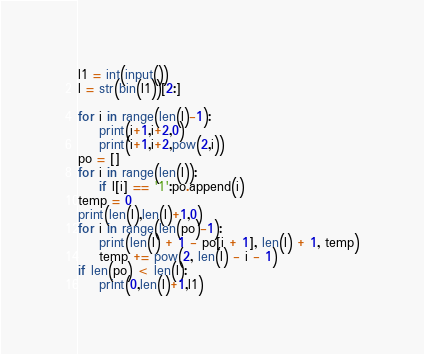Convert code to text. <code><loc_0><loc_0><loc_500><loc_500><_Python_>l1 = int(input())
l = str(bin(l1))[2:]

for i in range(len(l)-1):
    print(i+1,i+2,0)
    print(i+1,i+2,pow(2,i))
po = []
for i in range(len(l)):
    if l[i] == '1':po.append(i)
temp = 0
print(len(l),len(l)+1,0)
for i in range(len(po)-1):
    print(len(l) + 1 - po[i + 1], len(l) + 1, temp)
    temp += pow(2, len(l) - i - 1)
if len(po) < len(l):
    print(0,len(l)+1,l1)</code> 